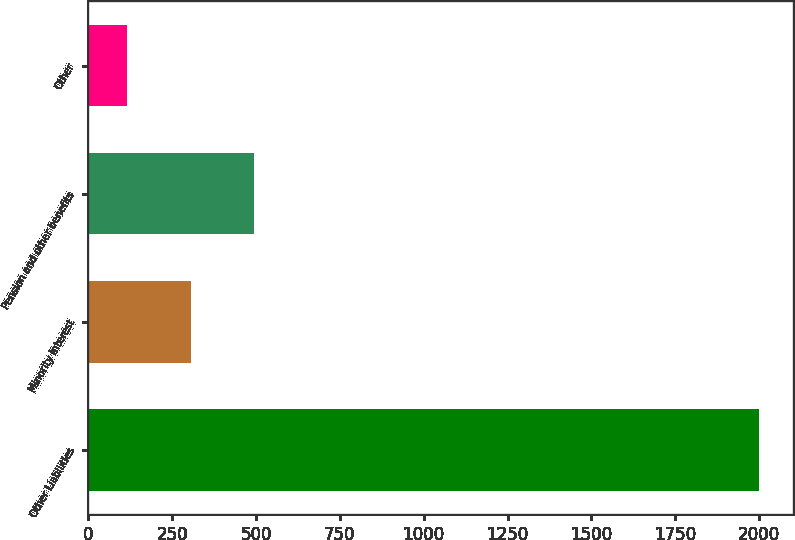Convert chart. <chart><loc_0><loc_0><loc_500><loc_500><bar_chart><fcel>Other Liabilities<fcel>Minority interest<fcel>Pension and other benefits<fcel>Other<nl><fcel>2001<fcel>305.13<fcel>493.56<fcel>116.7<nl></chart> 